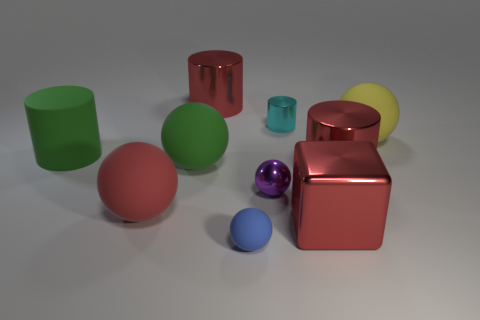Are there any large gray matte things of the same shape as the blue object?
Make the answer very short. No. Does the purple shiny object have the same shape as the big red metallic object in front of the purple shiny thing?
Ensure brevity in your answer.  No. There is a rubber object that is on the left side of the blue thing and behind the large green matte sphere; what size is it?
Give a very brief answer. Large. How many small blue balls are there?
Your response must be concise. 1. There is a cylinder that is the same size as the blue ball; what material is it?
Give a very brief answer. Metal. Is there a matte cylinder that has the same size as the purple metallic thing?
Give a very brief answer. No. There is a metallic cylinder on the left side of the blue sphere; is its color the same as the big metallic cylinder on the right side of the blue object?
Ensure brevity in your answer.  Yes. What number of rubber objects are either big things or small purple spheres?
Your answer should be very brief. 4. There is a tiny ball that is behind the matte sphere in front of the red block; how many big things are in front of it?
Ensure brevity in your answer.  2. There is a purple object that is the same material as the small cylinder; what size is it?
Your answer should be very brief. Small. 